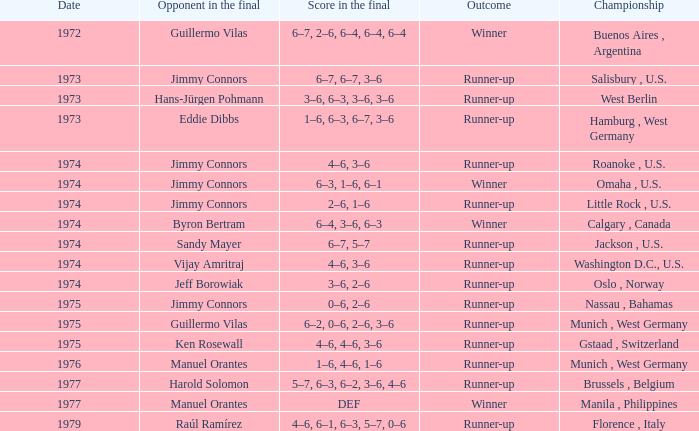What was the final score with Guillermo Vilas as the opponent in the final, that happened after 1972? 6–2, 0–6, 2–6, 3–6. 